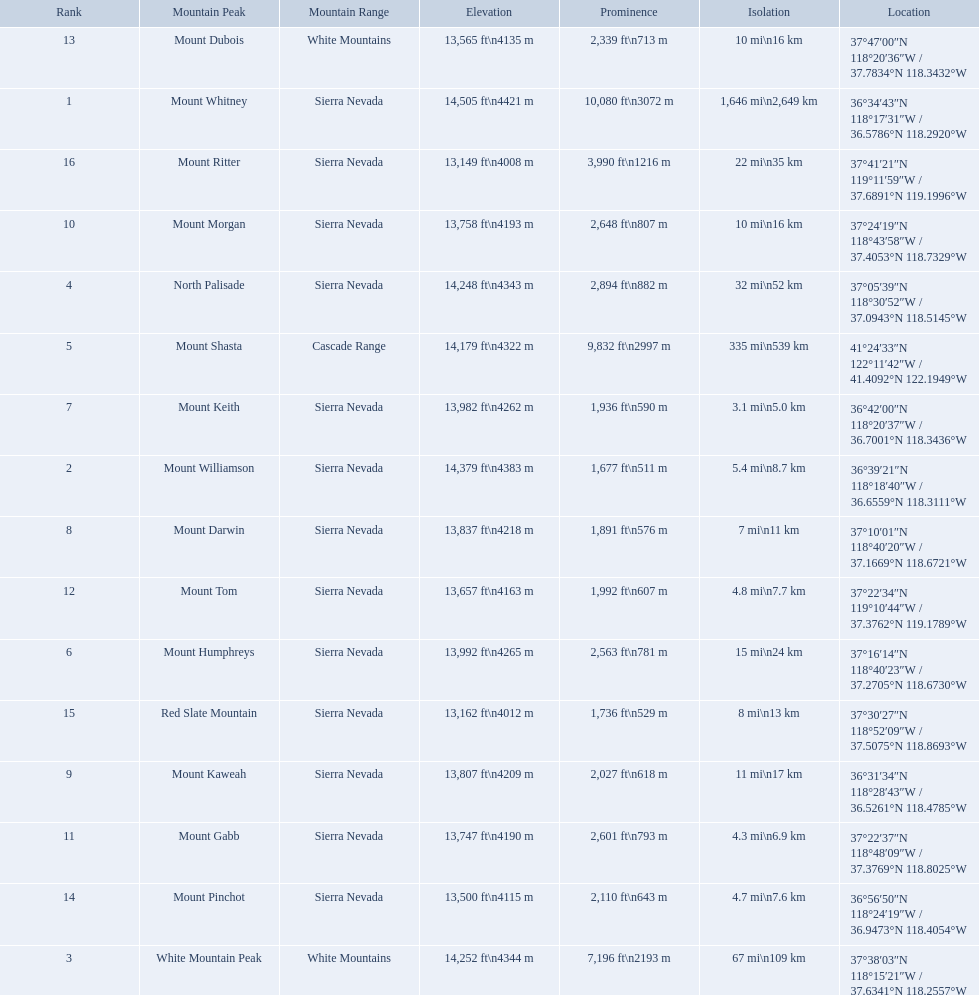What are the mountain peaks? Mount Whitney, Mount Williamson, White Mountain Peak, North Palisade, Mount Shasta, Mount Humphreys, Mount Keith, Mount Darwin, Mount Kaweah, Mount Morgan, Mount Gabb, Mount Tom, Mount Dubois, Mount Pinchot, Red Slate Mountain, Mount Ritter. Of these, which one has a prominence more than 10,000 ft? Mount Whitney. What are the prominence lengths higher than 10,000 feet? 10,080 ft\n3072 m. What mountain peak has a prominence of 10,080 feet? Mount Whitney. What are the heights of the peaks? 14,505 ft\n4421 m, 14,379 ft\n4383 m, 14,252 ft\n4344 m, 14,248 ft\n4343 m, 14,179 ft\n4322 m, 13,992 ft\n4265 m, 13,982 ft\n4262 m, 13,837 ft\n4218 m, 13,807 ft\n4209 m, 13,758 ft\n4193 m, 13,747 ft\n4190 m, 13,657 ft\n4163 m, 13,565 ft\n4135 m, 13,500 ft\n4115 m, 13,162 ft\n4012 m, 13,149 ft\n4008 m. Which of these heights is tallest? 14,505 ft\n4421 m. Could you parse the entire table? {'header': ['Rank', 'Mountain Peak', 'Mountain Range', 'Elevation', 'Prominence', 'Isolation', 'Location'], 'rows': [['13', 'Mount Dubois', 'White Mountains', '13,565\xa0ft\\n4135\xa0m', '2,339\xa0ft\\n713\xa0m', '10\xa0mi\\n16\xa0km', '37°47′00″N 118°20′36″W\ufeff / \ufeff37.7834°N 118.3432°W'], ['1', 'Mount Whitney', 'Sierra Nevada', '14,505\xa0ft\\n4421\xa0m', '10,080\xa0ft\\n3072\xa0m', '1,646\xa0mi\\n2,649\xa0km', '36°34′43″N 118°17′31″W\ufeff / \ufeff36.5786°N 118.2920°W'], ['16', 'Mount Ritter', 'Sierra Nevada', '13,149\xa0ft\\n4008\xa0m', '3,990\xa0ft\\n1216\xa0m', '22\xa0mi\\n35\xa0km', '37°41′21″N 119°11′59″W\ufeff / \ufeff37.6891°N 119.1996°W'], ['10', 'Mount Morgan', 'Sierra Nevada', '13,758\xa0ft\\n4193\xa0m', '2,648\xa0ft\\n807\xa0m', '10\xa0mi\\n16\xa0km', '37°24′19″N 118°43′58″W\ufeff / \ufeff37.4053°N 118.7329°W'], ['4', 'North Palisade', 'Sierra Nevada', '14,248\xa0ft\\n4343\xa0m', '2,894\xa0ft\\n882\xa0m', '32\xa0mi\\n52\xa0km', '37°05′39″N 118°30′52″W\ufeff / \ufeff37.0943°N 118.5145°W'], ['5', 'Mount Shasta', 'Cascade Range', '14,179\xa0ft\\n4322\xa0m', '9,832\xa0ft\\n2997\xa0m', '335\xa0mi\\n539\xa0km', '41°24′33″N 122°11′42″W\ufeff / \ufeff41.4092°N 122.1949°W'], ['7', 'Mount Keith', 'Sierra Nevada', '13,982\xa0ft\\n4262\xa0m', '1,936\xa0ft\\n590\xa0m', '3.1\xa0mi\\n5.0\xa0km', '36°42′00″N 118°20′37″W\ufeff / \ufeff36.7001°N 118.3436°W'], ['2', 'Mount Williamson', 'Sierra Nevada', '14,379\xa0ft\\n4383\xa0m', '1,677\xa0ft\\n511\xa0m', '5.4\xa0mi\\n8.7\xa0km', '36°39′21″N 118°18′40″W\ufeff / \ufeff36.6559°N 118.3111°W'], ['8', 'Mount Darwin', 'Sierra Nevada', '13,837\xa0ft\\n4218\xa0m', '1,891\xa0ft\\n576\xa0m', '7\xa0mi\\n11\xa0km', '37°10′01″N 118°40′20″W\ufeff / \ufeff37.1669°N 118.6721°W'], ['12', 'Mount Tom', 'Sierra Nevada', '13,657\xa0ft\\n4163\xa0m', '1,992\xa0ft\\n607\xa0m', '4.8\xa0mi\\n7.7\xa0km', '37°22′34″N 119°10′44″W\ufeff / \ufeff37.3762°N 119.1789°W'], ['6', 'Mount Humphreys', 'Sierra Nevada', '13,992\xa0ft\\n4265\xa0m', '2,563\xa0ft\\n781\xa0m', '15\xa0mi\\n24\xa0km', '37°16′14″N 118°40′23″W\ufeff / \ufeff37.2705°N 118.6730°W'], ['15', 'Red Slate Mountain', 'Sierra Nevada', '13,162\xa0ft\\n4012\xa0m', '1,736\xa0ft\\n529\xa0m', '8\xa0mi\\n13\xa0km', '37°30′27″N 118°52′09″W\ufeff / \ufeff37.5075°N 118.8693°W'], ['9', 'Mount Kaweah', 'Sierra Nevada', '13,807\xa0ft\\n4209\xa0m', '2,027\xa0ft\\n618\xa0m', '11\xa0mi\\n17\xa0km', '36°31′34″N 118°28′43″W\ufeff / \ufeff36.5261°N 118.4785°W'], ['11', 'Mount Gabb', 'Sierra Nevada', '13,747\xa0ft\\n4190\xa0m', '2,601\xa0ft\\n793\xa0m', '4.3\xa0mi\\n6.9\xa0km', '37°22′37″N 118°48′09″W\ufeff / \ufeff37.3769°N 118.8025°W'], ['14', 'Mount Pinchot', 'Sierra Nevada', '13,500\xa0ft\\n4115\xa0m', '2,110\xa0ft\\n643\xa0m', '4.7\xa0mi\\n7.6\xa0km', '36°56′50″N 118°24′19″W\ufeff / \ufeff36.9473°N 118.4054°W'], ['3', 'White Mountain Peak', 'White Mountains', '14,252\xa0ft\\n4344\xa0m', '7,196\xa0ft\\n2193\xa0m', '67\xa0mi\\n109\xa0km', '37°38′03″N 118°15′21″W\ufeff / \ufeff37.6341°N 118.2557°W']]} What peak is 14,505 feet? Mount Whitney. 